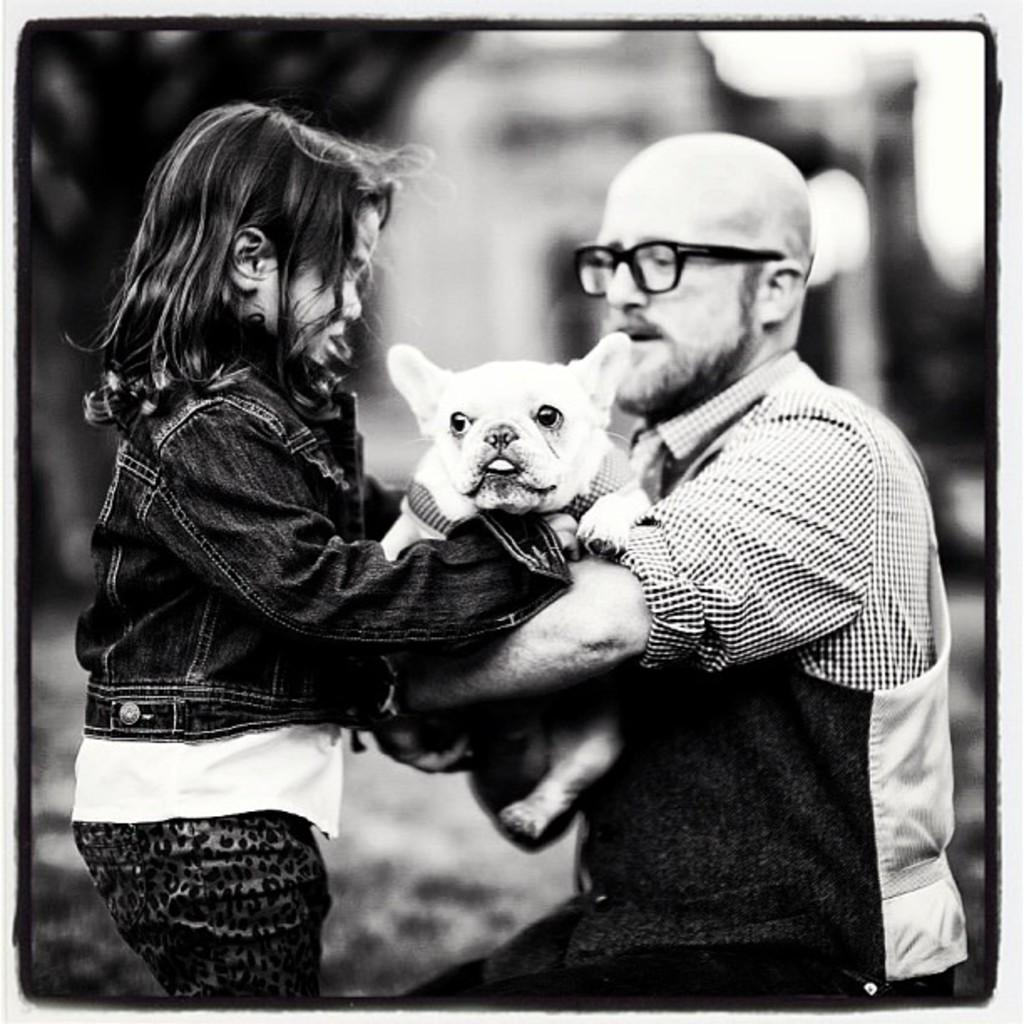Who is on the right side of the image? There is a person on the right side of the image. Who is on the left side of the image? There is a girl on the left side of the image. What is the person doing in the image? The person is giving a dog to the girl. What type of agreement is being signed by the person in the image? There is no agreement being signed in the image; the person is giving a dog to the girl. What color is the jelly on the front side of the image? There is no jelly present in the image. 